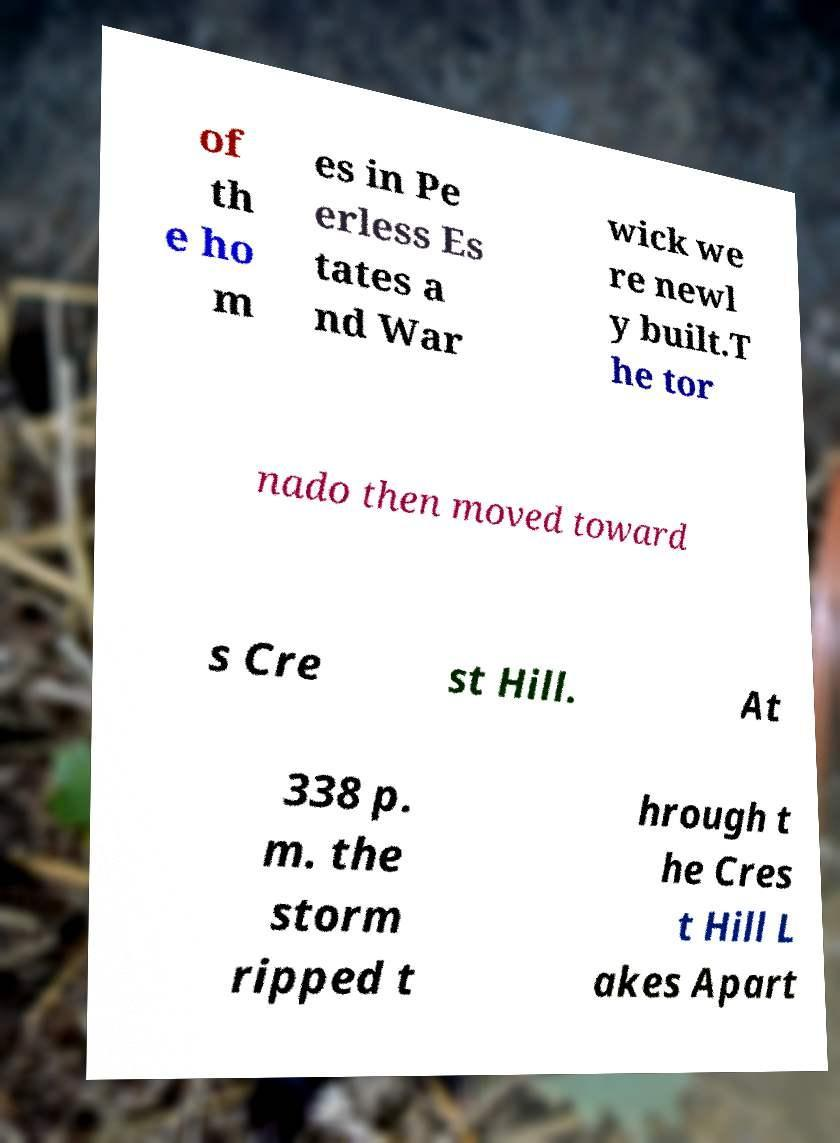For documentation purposes, I need the text within this image transcribed. Could you provide that? of th e ho m es in Pe erless Es tates a nd War wick we re newl y built.T he tor nado then moved toward s Cre st Hill. At 338 p. m. the storm ripped t hrough t he Cres t Hill L akes Apart 